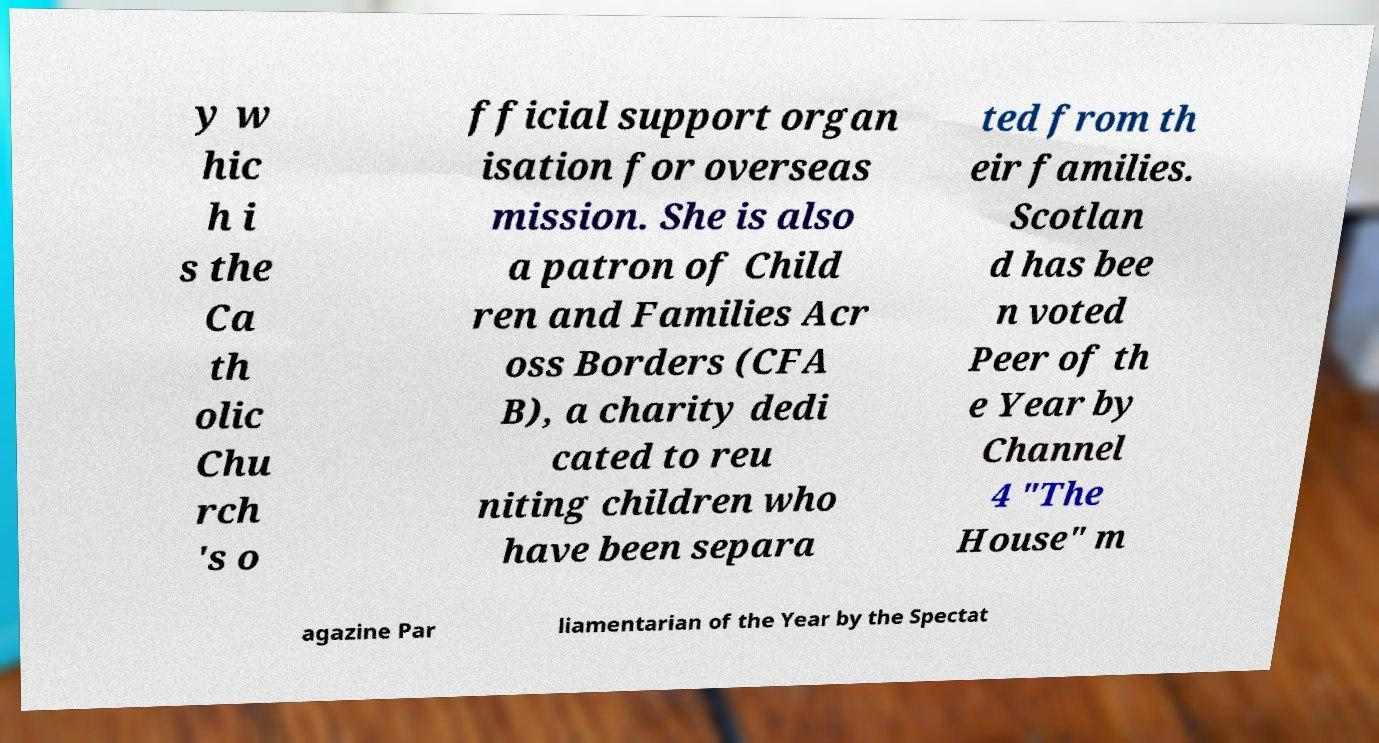There's text embedded in this image that I need extracted. Can you transcribe it verbatim? y w hic h i s the Ca th olic Chu rch 's o fficial support organ isation for overseas mission. She is also a patron of Child ren and Families Acr oss Borders (CFA B), a charity dedi cated to reu niting children who have been separa ted from th eir families. Scotlan d has bee n voted Peer of th e Year by Channel 4 "The House" m agazine Par liamentarian of the Year by the Spectat 